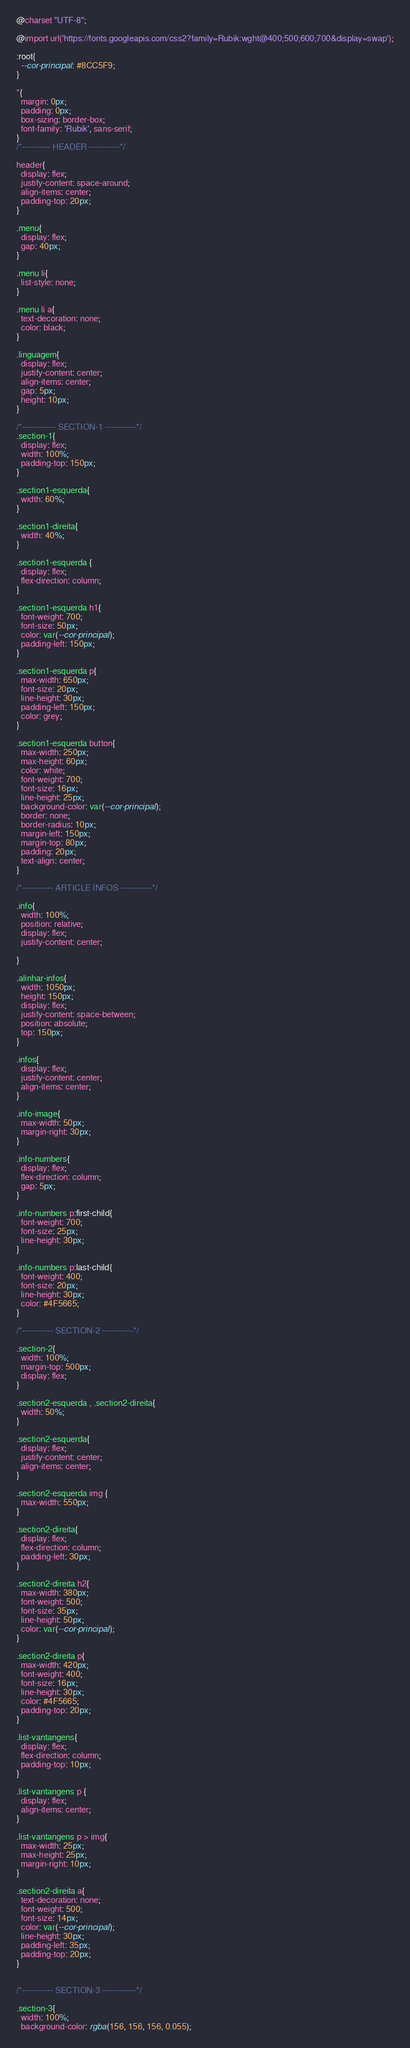Convert code to text. <code><loc_0><loc_0><loc_500><loc_500><_CSS_>@charset "UTF-8";

@import url('https://fonts.googleapis.com/css2?family=Rubik:wght@400;500;600;700&display=swap');

:root{
  --cor-principal: #8CC5F9;
}

*{
  margin: 0px;
  padding: 0px;
  box-sizing: border-box;
  font-family: 'Rubik', sans-serif;
}
/*---------- HEADER -----------*/

header{
  display: flex;
  justify-content: space-around;
  align-items: center;
  padding-top: 20px;
}

.menu{
  display: flex;
  gap: 40px;
}

.menu li{
  list-style: none;
}

.menu li a{
  text-decoration: none;
  color: black;
}

.linguagem{
  display: flex;
  justify-content: center;
  align-items: center;
  gap: 5px;
  height: 10px;
}

/*------------ SECTION-1 -----------*/
.section-1{
  display: flex;
  width: 100%;
  padding-top: 150px;
}

.section1-esquerda{
  width: 60%;
}

.section1-direita{
  width: 40%;
}

.section1-esquerda {
  display: flex;
  flex-direction: column;
}

.section1-esquerda h1{
  font-weight: 700;
  font-size: 50px;
  color: var(--cor-principal);
  padding-left: 150px;
}

.section1-esquerda p{
  max-width: 650px;
  font-size: 20px;
  line-height: 30px;
  padding-left: 150px;
  color: grey;
}

.section1-esquerda button{
  max-width: 250px;
  max-height: 60px;
  color: white;
  font-weight: 700;
  font-size: 16px;
  line-height: 25px;
  background-color: var(--cor-principal);
  border: none;
  border-radius: 10px;
  margin-left: 150px;
  margin-top: 80px;
  padding: 20px;
  text-align: center;
}

/*----------- ARTICLE INFOS -----------*/

.info{
  width: 100%;
  position: relative;
  display: flex;
  justify-content: center;

}

.alinhar-infos{
  width: 1050px;
  height: 150px;
  display: flex;
  justify-content: space-between;
  position: absolute;
  top: 150px;
}

.infos{
  display: flex;
  justify-content: center;
  align-items: center;
}

.info-image{
  max-width: 50px;
  margin-right: 30px;
}

.info-numbers{
  display: flex;
  flex-direction: column;
  gap: 5px;
}

.info-numbers p:first-child{
  font-weight: 700;
  font-size: 25px;
  line-height: 30px;
}

.info-numbers p:last-child{
  font-weight: 400;
  font-size: 20px;
  line-height: 30px;
  color: #4F5665;
}

/*----------- SECTION-2 -----------*/

.section-2{
  width: 100%;
  margin-top: 500px;
  display: flex;
}

.section2-esquerda , .section2-direita{
  width: 50%;
}

.section2-esquerda{
  display: flex;
  justify-content: center;
  align-items: center;
}

.section2-esquerda img {
  max-width: 550px;
}

.section2-direita{
  display: flex;
  flex-direction: column;
  padding-left: 30px;
}

.section2-direita h2{
  max-width: 380px;
  font-weight: 500;
  font-size: 35px;
  line-height: 50px;
  color: var(--cor-principal);
}

.section2-direita p{
  max-width: 420px;
  font-weight: 400;
  font-size: 16px;
  line-height: 30px;
  color: #4F5665;
  padding-top: 20px;
}

.list-vantangens{
  display: flex;
  flex-direction: column;
  padding-top: 10px;
}

.list-vantangens p {
  display: flex;
  align-items: center;
}

.list-vantangens p > img{
  max-width: 25px;
  max-height: 25px;
  margin-right: 10px;
}

.section2-direita a{
  text-decoration: none;
  font-weight: 500;
  font-size: 14px;
  color: var(--cor-principal);
  line-height: 30px;
  padding-left: 35px;
  padding-top: 20px;
}


/*----------- SECTION-3 ------------*/

.section-3{
  width: 100%;
  background-color: rgba(156, 156, 156, 0.055);</code> 